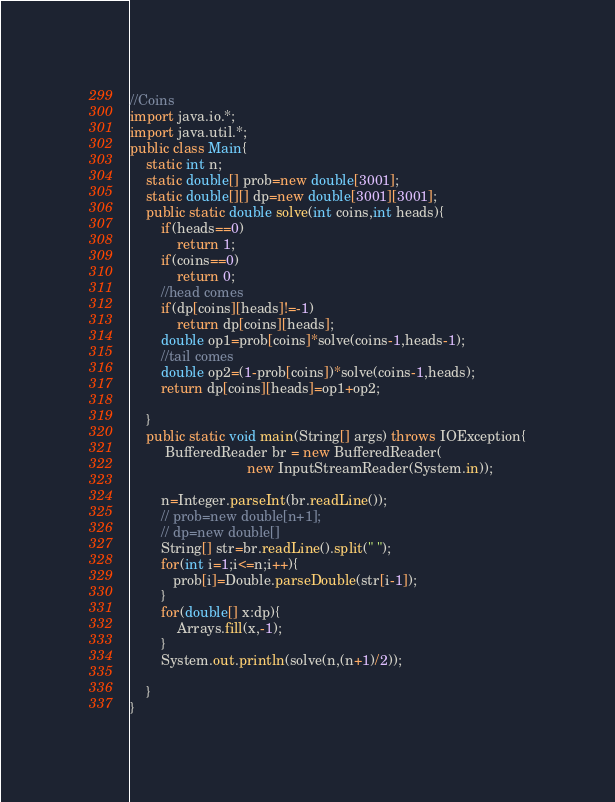Convert code to text. <code><loc_0><loc_0><loc_500><loc_500><_Java_>//Coins
import java.io.*;
import java.util.*;
public class Main{
	static int n;
	static double[] prob=new double[3001];
	static double[][] dp=new double[3001][3001];
	public static double solve(int coins,int heads){
		if(heads==0)
			return 1;
		if(coins==0)
			return 0;
		//head comes
		if(dp[coins][heads]!=-1)
			return dp[coins][heads];
		double op1=prob[coins]*solve(coins-1,heads-1);
		//tail comes
		double op2=(1-prob[coins])*solve(coins-1,heads);
		return dp[coins][heads]=op1+op2;

	}
	public static void main(String[] args) throws IOException{
    	 BufferedReader br = new BufferedReader( 
                              new InputStreamReader(System.in)); 
       
		n=Integer.parseInt(br.readLine()); 
		// prob=new double[n+1];
		// dp=new double[]
		String[] str=br.readLine().split(" ");
		for(int i=1;i<=n;i++){			
		   prob[i]=Double.parseDouble(str[i-1]);		 
		}
		for(double[] x:dp){
			Arrays.fill(x,-1);
		}
		System.out.println(solve(n,(n+1)/2));
	
    }
}</code> 